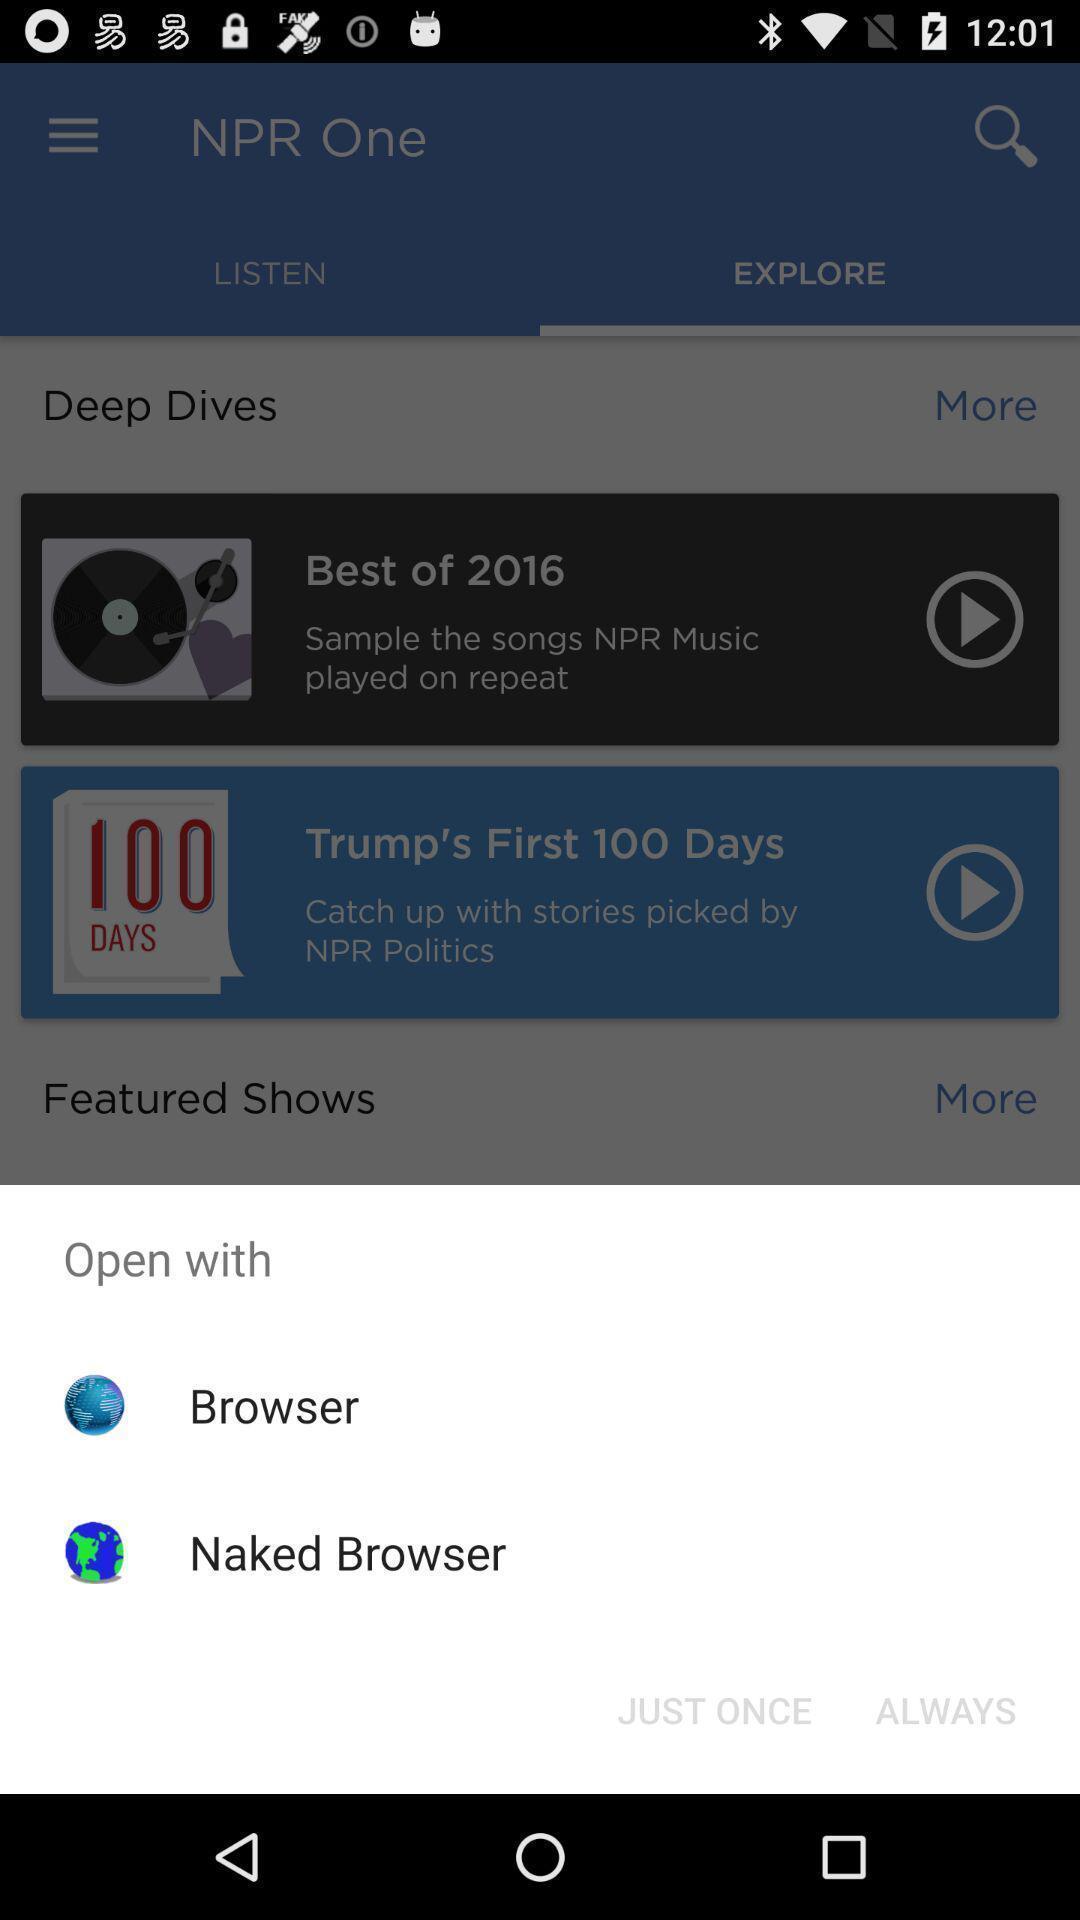Tell me what you see in this picture. Popup showing open file with browsing options in radio app. 